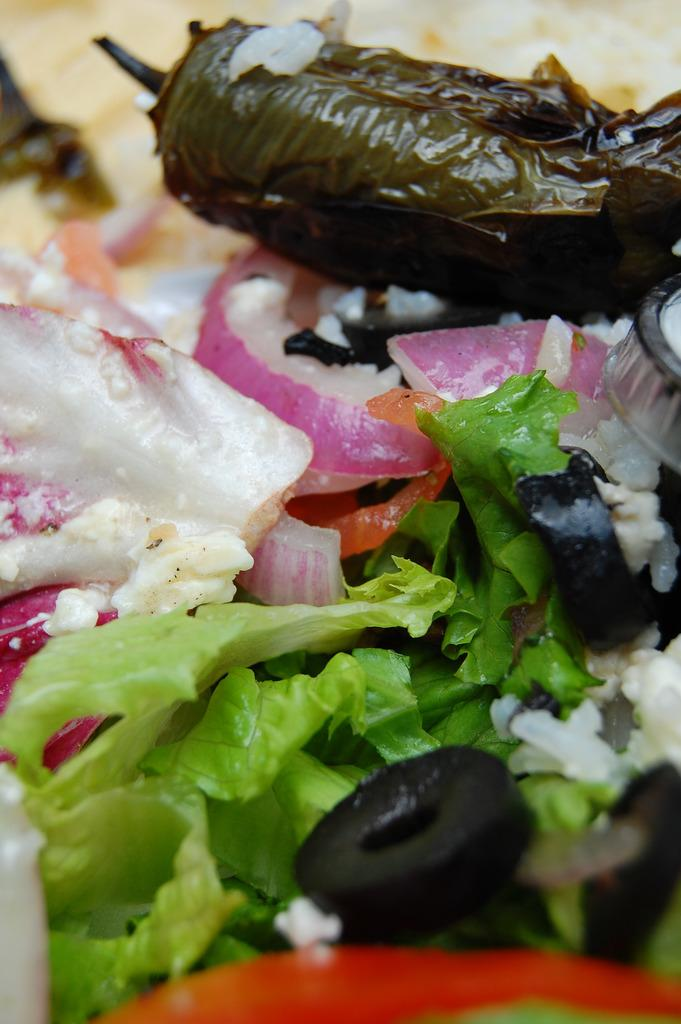What can be seen in the foreground of the image? There are food items in the foreground of the image. How many straws are sticking out of the pies in the image? There is no mention of pies or straws in the image, so we cannot answer this question. 